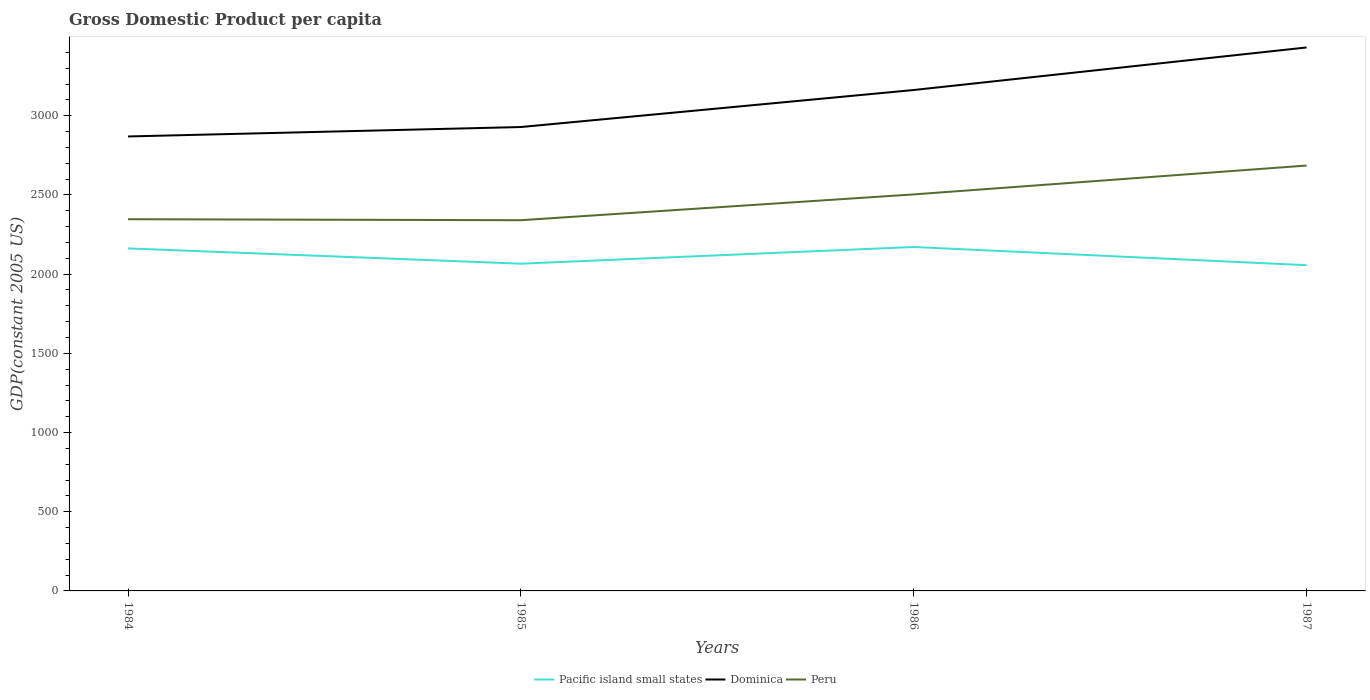Is the number of lines equal to the number of legend labels?
Make the answer very short. Yes. Across all years, what is the maximum GDP per capita in Peru?
Provide a succinct answer. 2340.48. What is the total GDP per capita in Peru in the graph?
Offer a very short reply. -156.6. What is the difference between the highest and the second highest GDP per capita in Pacific island small states?
Make the answer very short. 114.85. Is the GDP per capita in Peru strictly greater than the GDP per capita in Pacific island small states over the years?
Your answer should be very brief. No. What is the difference between two consecutive major ticks on the Y-axis?
Ensure brevity in your answer.  500. Are the values on the major ticks of Y-axis written in scientific E-notation?
Offer a terse response. No. How are the legend labels stacked?
Your response must be concise. Horizontal. What is the title of the graph?
Provide a succinct answer. Gross Domestic Product per capita. Does "Tajikistan" appear as one of the legend labels in the graph?
Offer a terse response. No. What is the label or title of the X-axis?
Ensure brevity in your answer.  Years. What is the label or title of the Y-axis?
Your answer should be compact. GDP(constant 2005 US). What is the GDP(constant 2005 US) in Pacific island small states in 1984?
Your answer should be compact. 2162.4. What is the GDP(constant 2005 US) of Dominica in 1984?
Make the answer very short. 2869.16. What is the GDP(constant 2005 US) in Peru in 1984?
Give a very brief answer. 2346.69. What is the GDP(constant 2005 US) of Pacific island small states in 1985?
Your answer should be very brief. 2065.9. What is the GDP(constant 2005 US) of Dominica in 1985?
Offer a very short reply. 2928.71. What is the GDP(constant 2005 US) in Peru in 1985?
Keep it short and to the point. 2340.48. What is the GDP(constant 2005 US) in Pacific island small states in 1986?
Offer a very short reply. 2171.34. What is the GDP(constant 2005 US) of Dominica in 1986?
Give a very brief answer. 3162.41. What is the GDP(constant 2005 US) of Peru in 1986?
Make the answer very short. 2503.3. What is the GDP(constant 2005 US) in Pacific island small states in 1987?
Make the answer very short. 2056.49. What is the GDP(constant 2005 US) in Dominica in 1987?
Ensure brevity in your answer.  3431.05. What is the GDP(constant 2005 US) in Peru in 1987?
Make the answer very short. 2685.6. Across all years, what is the maximum GDP(constant 2005 US) in Pacific island small states?
Your answer should be compact. 2171.34. Across all years, what is the maximum GDP(constant 2005 US) in Dominica?
Your response must be concise. 3431.05. Across all years, what is the maximum GDP(constant 2005 US) in Peru?
Keep it short and to the point. 2685.6. Across all years, what is the minimum GDP(constant 2005 US) in Pacific island small states?
Offer a terse response. 2056.49. Across all years, what is the minimum GDP(constant 2005 US) in Dominica?
Make the answer very short. 2869.16. Across all years, what is the minimum GDP(constant 2005 US) in Peru?
Make the answer very short. 2340.48. What is the total GDP(constant 2005 US) of Pacific island small states in the graph?
Make the answer very short. 8456.12. What is the total GDP(constant 2005 US) in Dominica in the graph?
Make the answer very short. 1.24e+04. What is the total GDP(constant 2005 US) of Peru in the graph?
Keep it short and to the point. 9876.07. What is the difference between the GDP(constant 2005 US) of Pacific island small states in 1984 and that in 1985?
Your answer should be compact. 96.5. What is the difference between the GDP(constant 2005 US) in Dominica in 1984 and that in 1985?
Provide a short and direct response. -59.55. What is the difference between the GDP(constant 2005 US) in Peru in 1984 and that in 1985?
Ensure brevity in your answer.  6.21. What is the difference between the GDP(constant 2005 US) of Pacific island small states in 1984 and that in 1986?
Provide a succinct answer. -8.94. What is the difference between the GDP(constant 2005 US) of Dominica in 1984 and that in 1986?
Make the answer very short. -293.24. What is the difference between the GDP(constant 2005 US) of Peru in 1984 and that in 1986?
Give a very brief answer. -156.6. What is the difference between the GDP(constant 2005 US) of Pacific island small states in 1984 and that in 1987?
Your response must be concise. 105.91. What is the difference between the GDP(constant 2005 US) of Dominica in 1984 and that in 1987?
Provide a short and direct response. -561.88. What is the difference between the GDP(constant 2005 US) in Peru in 1984 and that in 1987?
Make the answer very short. -338.91. What is the difference between the GDP(constant 2005 US) of Pacific island small states in 1985 and that in 1986?
Offer a terse response. -105.44. What is the difference between the GDP(constant 2005 US) of Dominica in 1985 and that in 1986?
Your answer should be compact. -233.7. What is the difference between the GDP(constant 2005 US) of Peru in 1985 and that in 1986?
Provide a succinct answer. -162.81. What is the difference between the GDP(constant 2005 US) in Pacific island small states in 1985 and that in 1987?
Your answer should be compact. 9.41. What is the difference between the GDP(constant 2005 US) in Dominica in 1985 and that in 1987?
Give a very brief answer. -502.34. What is the difference between the GDP(constant 2005 US) of Peru in 1985 and that in 1987?
Offer a very short reply. -345.11. What is the difference between the GDP(constant 2005 US) of Pacific island small states in 1986 and that in 1987?
Offer a very short reply. 114.85. What is the difference between the GDP(constant 2005 US) in Dominica in 1986 and that in 1987?
Keep it short and to the point. -268.64. What is the difference between the GDP(constant 2005 US) in Peru in 1986 and that in 1987?
Provide a succinct answer. -182.3. What is the difference between the GDP(constant 2005 US) of Pacific island small states in 1984 and the GDP(constant 2005 US) of Dominica in 1985?
Your answer should be compact. -766.31. What is the difference between the GDP(constant 2005 US) of Pacific island small states in 1984 and the GDP(constant 2005 US) of Peru in 1985?
Offer a very short reply. -178.09. What is the difference between the GDP(constant 2005 US) in Dominica in 1984 and the GDP(constant 2005 US) in Peru in 1985?
Offer a terse response. 528.68. What is the difference between the GDP(constant 2005 US) of Pacific island small states in 1984 and the GDP(constant 2005 US) of Dominica in 1986?
Provide a succinct answer. -1000.01. What is the difference between the GDP(constant 2005 US) in Pacific island small states in 1984 and the GDP(constant 2005 US) in Peru in 1986?
Provide a succinct answer. -340.9. What is the difference between the GDP(constant 2005 US) in Dominica in 1984 and the GDP(constant 2005 US) in Peru in 1986?
Your response must be concise. 365.87. What is the difference between the GDP(constant 2005 US) in Pacific island small states in 1984 and the GDP(constant 2005 US) in Dominica in 1987?
Your response must be concise. -1268.65. What is the difference between the GDP(constant 2005 US) of Pacific island small states in 1984 and the GDP(constant 2005 US) of Peru in 1987?
Provide a short and direct response. -523.2. What is the difference between the GDP(constant 2005 US) in Dominica in 1984 and the GDP(constant 2005 US) in Peru in 1987?
Your response must be concise. 183.56. What is the difference between the GDP(constant 2005 US) in Pacific island small states in 1985 and the GDP(constant 2005 US) in Dominica in 1986?
Make the answer very short. -1096.51. What is the difference between the GDP(constant 2005 US) in Pacific island small states in 1985 and the GDP(constant 2005 US) in Peru in 1986?
Provide a short and direct response. -437.4. What is the difference between the GDP(constant 2005 US) of Dominica in 1985 and the GDP(constant 2005 US) of Peru in 1986?
Your response must be concise. 425.42. What is the difference between the GDP(constant 2005 US) of Pacific island small states in 1985 and the GDP(constant 2005 US) of Dominica in 1987?
Provide a succinct answer. -1365.15. What is the difference between the GDP(constant 2005 US) of Pacific island small states in 1985 and the GDP(constant 2005 US) of Peru in 1987?
Keep it short and to the point. -619.7. What is the difference between the GDP(constant 2005 US) in Dominica in 1985 and the GDP(constant 2005 US) in Peru in 1987?
Offer a very short reply. 243.11. What is the difference between the GDP(constant 2005 US) of Pacific island small states in 1986 and the GDP(constant 2005 US) of Dominica in 1987?
Offer a terse response. -1259.71. What is the difference between the GDP(constant 2005 US) in Pacific island small states in 1986 and the GDP(constant 2005 US) in Peru in 1987?
Keep it short and to the point. -514.26. What is the difference between the GDP(constant 2005 US) in Dominica in 1986 and the GDP(constant 2005 US) in Peru in 1987?
Offer a very short reply. 476.81. What is the average GDP(constant 2005 US) of Pacific island small states per year?
Your answer should be compact. 2114.03. What is the average GDP(constant 2005 US) in Dominica per year?
Offer a terse response. 3097.83. What is the average GDP(constant 2005 US) in Peru per year?
Give a very brief answer. 2469.02. In the year 1984, what is the difference between the GDP(constant 2005 US) of Pacific island small states and GDP(constant 2005 US) of Dominica?
Your answer should be very brief. -706.76. In the year 1984, what is the difference between the GDP(constant 2005 US) in Pacific island small states and GDP(constant 2005 US) in Peru?
Your response must be concise. -184.29. In the year 1984, what is the difference between the GDP(constant 2005 US) in Dominica and GDP(constant 2005 US) in Peru?
Give a very brief answer. 522.47. In the year 1985, what is the difference between the GDP(constant 2005 US) of Pacific island small states and GDP(constant 2005 US) of Dominica?
Make the answer very short. -862.81. In the year 1985, what is the difference between the GDP(constant 2005 US) in Pacific island small states and GDP(constant 2005 US) in Peru?
Your answer should be compact. -274.59. In the year 1985, what is the difference between the GDP(constant 2005 US) of Dominica and GDP(constant 2005 US) of Peru?
Your response must be concise. 588.23. In the year 1986, what is the difference between the GDP(constant 2005 US) in Pacific island small states and GDP(constant 2005 US) in Dominica?
Your answer should be very brief. -991.07. In the year 1986, what is the difference between the GDP(constant 2005 US) of Pacific island small states and GDP(constant 2005 US) of Peru?
Offer a terse response. -331.96. In the year 1986, what is the difference between the GDP(constant 2005 US) of Dominica and GDP(constant 2005 US) of Peru?
Your answer should be very brief. 659.11. In the year 1987, what is the difference between the GDP(constant 2005 US) in Pacific island small states and GDP(constant 2005 US) in Dominica?
Provide a short and direct response. -1374.56. In the year 1987, what is the difference between the GDP(constant 2005 US) of Pacific island small states and GDP(constant 2005 US) of Peru?
Your response must be concise. -629.11. In the year 1987, what is the difference between the GDP(constant 2005 US) in Dominica and GDP(constant 2005 US) in Peru?
Keep it short and to the point. 745.45. What is the ratio of the GDP(constant 2005 US) in Pacific island small states in 1984 to that in 1985?
Provide a short and direct response. 1.05. What is the ratio of the GDP(constant 2005 US) of Dominica in 1984 to that in 1985?
Your answer should be compact. 0.98. What is the ratio of the GDP(constant 2005 US) of Pacific island small states in 1984 to that in 1986?
Ensure brevity in your answer.  1. What is the ratio of the GDP(constant 2005 US) of Dominica in 1984 to that in 1986?
Offer a terse response. 0.91. What is the ratio of the GDP(constant 2005 US) of Peru in 1984 to that in 1986?
Offer a terse response. 0.94. What is the ratio of the GDP(constant 2005 US) of Pacific island small states in 1984 to that in 1987?
Ensure brevity in your answer.  1.05. What is the ratio of the GDP(constant 2005 US) of Dominica in 1984 to that in 1987?
Your response must be concise. 0.84. What is the ratio of the GDP(constant 2005 US) in Peru in 1984 to that in 1987?
Ensure brevity in your answer.  0.87. What is the ratio of the GDP(constant 2005 US) of Pacific island small states in 1985 to that in 1986?
Give a very brief answer. 0.95. What is the ratio of the GDP(constant 2005 US) of Dominica in 1985 to that in 1986?
Offer a terse response. 0.93. What is the ratio of the GDP(constant 2005 US) of Peru in 1985 to that in 1986?
Keep it short and to the point. 0.94. What is the ratio of the GDP(constant 2005 US) in Dominica in 1985 to that in 1987?
Give a very brief answer. 0.85. What is the ratio of the GDP(constant 2005 US) in Peru in 1985 to that in 1987?
Provide a succinct answer. 0.87. What is the ratio of the GDP(constant 2005 US) in Pacific island small states in 1986 to that in 1987?
Your answer should be very brief. 1.06. What is the ratio of the GDP(constant 2005 US) in Dominica in 1986 to that in 1987?
Make the answer very short. 0.92. What is the ratio of the GDP(constant 2005 US) of Peru in 1986 to that in 1987?
Provide a succinct answer. 0.93. What is the difference between the highest and the second highest GDP(constant 2005 US) of Pacific island small states?
Your answer should be compact. 8.94. What is the difference between the highest and the second highest GDP(constant 2005 US) of Dominica?
Offer a very short reply. 268.64. What is the difference between the highest and the second highest GDP(constant 2005 US) in Peru?
Your answer should be compact. 182.3. What is the difference between the highest and the lowest GDP(constant 2005 US) in Pacific island small states?
Make the answer very short. 114.85. What is the difference between the highest and the lowest GDP(constant 2005 US) of Dominica?
Make the answer very short. 561.88. What is the difference between the highest and the lowest GDP(constant 2005 US) of Peru?
Offer a terse response. 345.11. 